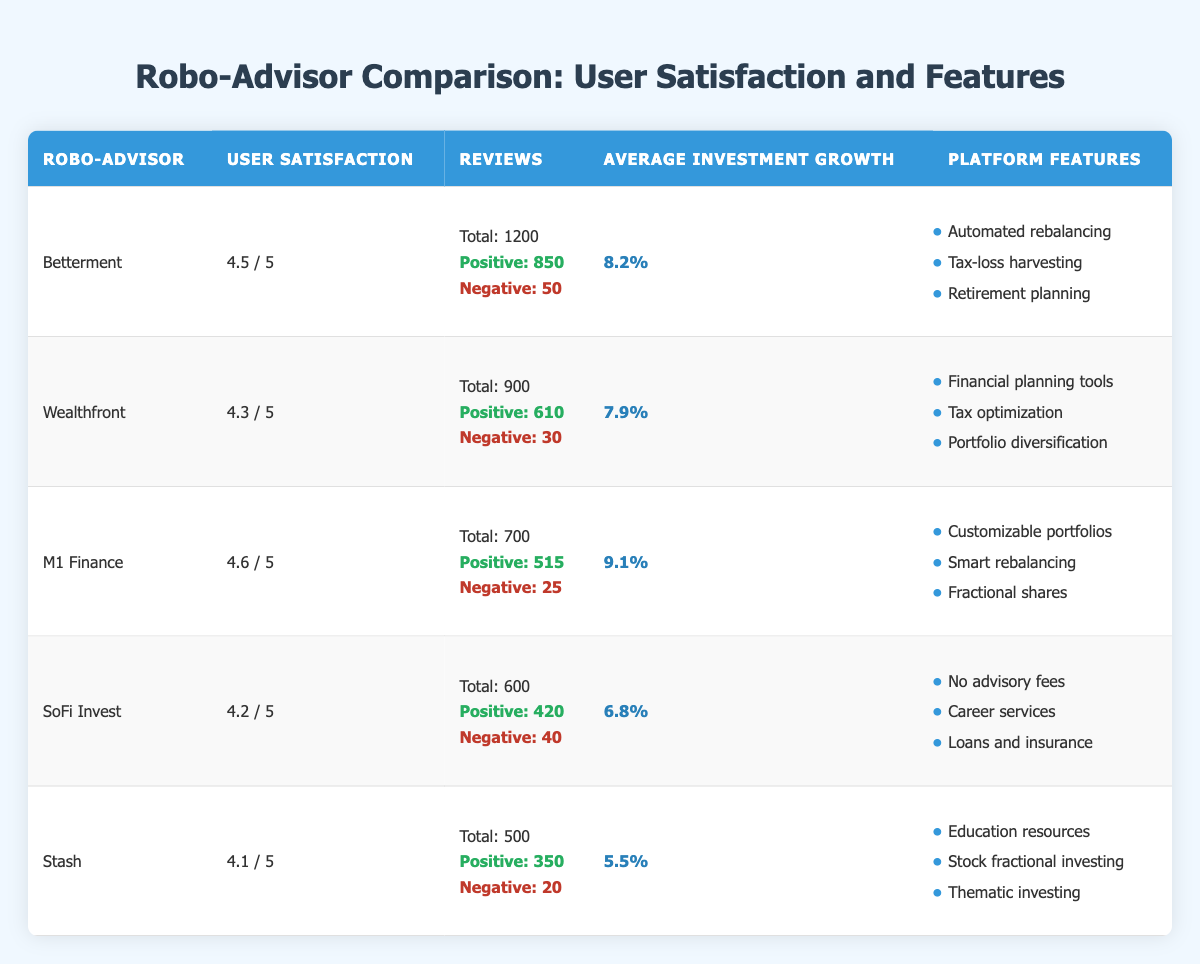What's the user satisfaction rating for Betterment? Directly locate Betterment in the table and find the corresponding value in the "User Satisfaction" column.
Answer: 4.5 / 5 How many reviews did Wealthfront receive in total? Look for Wealthfront in the table and refer to the "Reviews" column to find the total number of reviews.
Answer: Total: 900 Which robo-advisor has the highest average investment growth? Compare the values in the "Average Investment Growth" column for all robo-advisors, identifying that M1 Finance has the highest value at 9.1%.
Answer: M1 Finance What is the total number of positive reviews across all robo-advisors? Add the positive reviews for each robo-advisor: 850 + 610 + 515 + 420 + 350 = 2955.
Answer: 2955 Is SoFi Invest rated higher than Stash? Compare the user satisfaction ratings of SoFi Invest (4.2) and Stash (4.1) to determine which one is rated higher.
Answer: Yes How many more positive reviews does Betterment have than SoFi Invest? Subtract the positive reviews of SoFi Invest (420) from those of Betterment (850): 850 - 420 = 430.
Answer: 430 Which robo-advisor offers "Fractional shares" as one of its platform features? Check the "Platform Features" column for each robo-advisor to identify that M1 Finance includes "Fractional shares."
Answer: M1 Finance What's the percentage of negative reviews for Stash? First, find the number of negative reviews (20) and total reviews (500). Calculate negative review percentage: (20 / 500) * 100 = 4%.
Answer: 4% Which robo-advisor has the least number of reviews and what is that number? Review the "Reviews" column for all entries to find that Stash has the least with 500 total reviews.
Answer: 500 